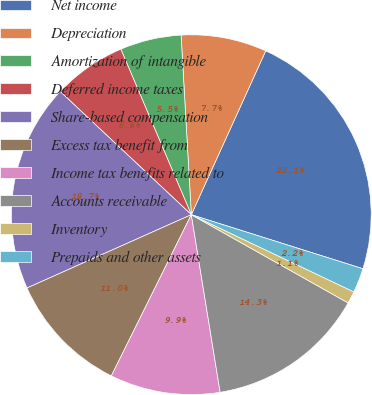<chart> <loc_0><loc_0><loc_500><loc_500><pie_chart><fcel>Net income<fcel>Depreciation<fcel>Amortization of intangible<fcel>Deferred income taxes<fcel>Share-based compensation<fcel>Excess tax benefit from<fcel>Income tax benefits related to<fcel>Accounts receivable<fcel>Inventory<fcel>Prepaids and other assets<nl><fcel>23.07%<fcel>7.69%<fcel>5.5%<fcel>6.59%<fcel>18.68%<fcel>10.99%<fcel>9.89%<fcel>14.28%<fcel>1.1%<fcel>2.2%<nl></chart> 